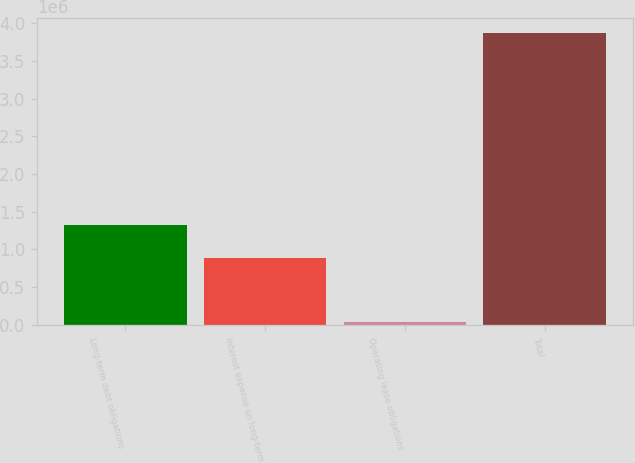Convert chart to OTSL. <chart><loc_0><loc_0><loc_500><loc_500><bar_chart><fcel>Long-term debt obligations<fcel>Interest expense on long-term<fcel>Operating lease obligations<fcel>Total<nl><fcel>1.32207e+06<fcel>889686<fcel>38561<fcel>3.87819e+06<nl></chart> 